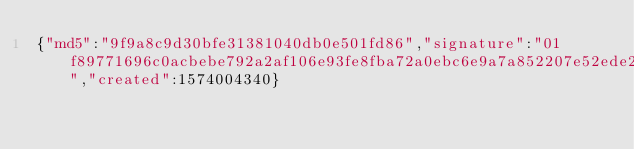Convert code to text. <code><loc_0><loc_0><loc_500><loc_500><_SML_>{"md5":"9f9a8c9d30bfe31381040db0e501fd86","signature":"01f89771696c0acbebe792a2af106e93fe8fba72a0ebc6e9a7a852207e52ede218383c244e5ef66b86565330809dc65ad25dfc6ca6c3b8f6ab88bafa5407d20a","created":1574004340}</code> 